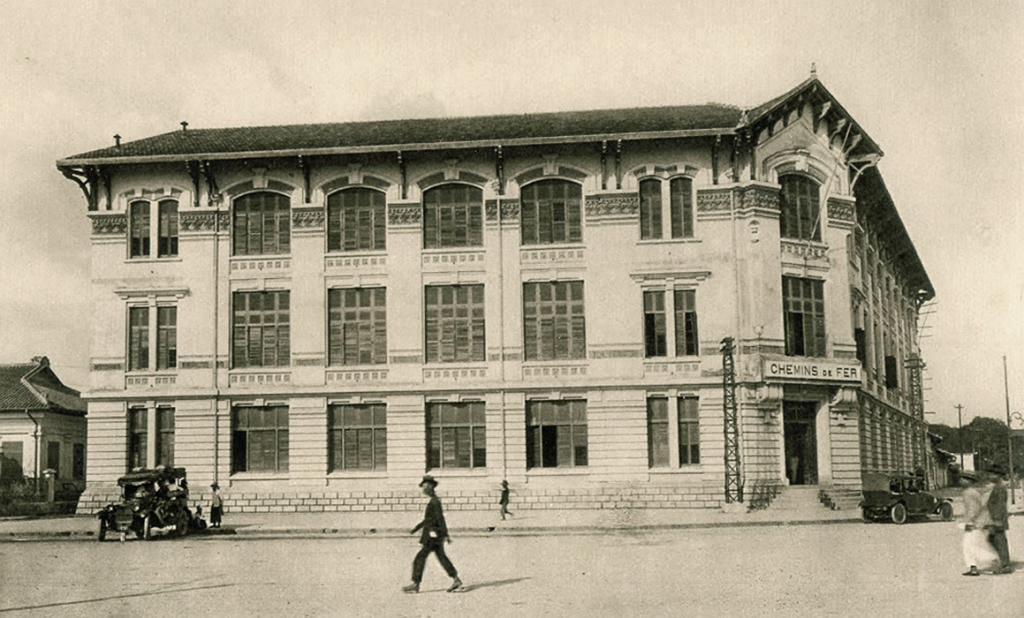What type of structures can be seen in the image? There are buildings in the image. How many vehicles are present in the image? There are 2 vehicles in the image. What is happening on the road in the image? There are people on the road in the image. What can be seen in the background of the image? The sky is visible in the background of the image. What else can be seen in the image besides buildings and vehicles? There are poles in the image. Can you tell me how many times the people in the image sneeze? There is no indication of sneezing in the image. What type of magic is being performed in the image? There is no magic or any magical elements present in the image. 